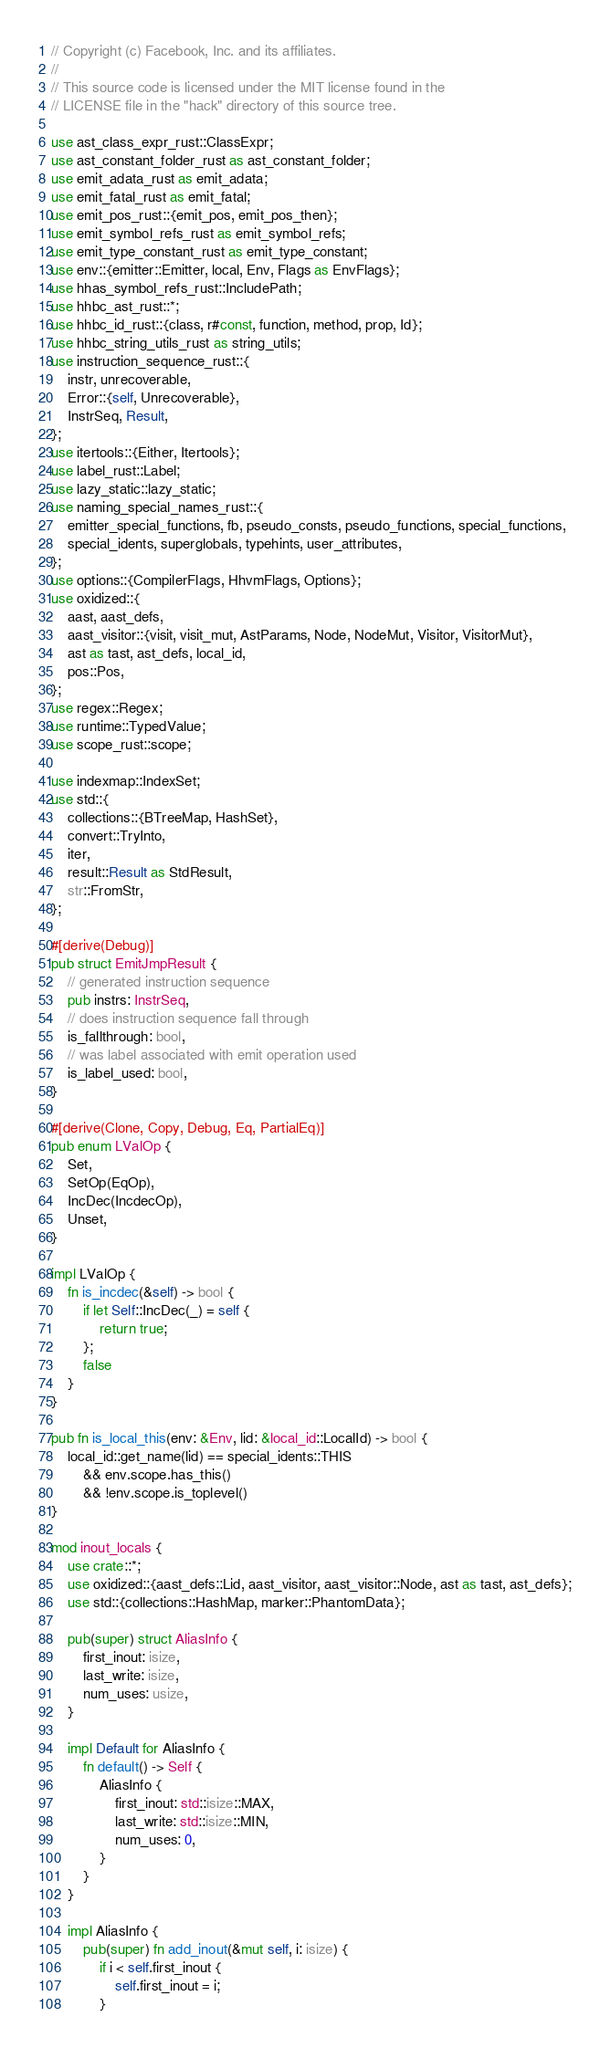Convert code to text. <code><loc_0><loc_0><loc_500><loc_500><_Rust_>// Copyright (c) Facebook, Inc. and its affiliates.
//
// This source code is licensed under the MIT license found in the
// LICENSE file in the "hack" directory of this source tree.

use ast_class_expr_rust::ClassExpr;
use ast_constant_folder_rust as ast_constant_folder;
use emit_adata_rust as emit_adata;
use emit_fatal_rust as emit_fatal;
use emit_pos_rust::{emit_pos, emit_pos_then};
use emit_symbol_refs_rust as emit_symbol_refs;
use emit_type_constant_rust as emit_type_constant;
use env::{emitter::Emitter, local, Env, Flags as EnvFlags};
use hhas_symbol_refs_rust::IncludePath;
use hhbc_ast_rust::*;
use hhbc_id_rust::{class, r#const, function, method, prop, Id};
use hhbc_string_utils_rust as string_utils;
use instruction_sequence_rust::{
    instr, unrecoverable,
    Error::{self, Unrecoverable},
    InstrSeq, Result,
};
use itertools::{Either, Itertools};
use label_rust::Label;
use lazy_static::lazy_static;
use naming_special_names_rust::{
    emitter_special_functions, fb, pseudo_consts, pseudo_functions, special_functions,
    special_idents, superglobals, typehints, user_attributes,
};
use options::{CompilerFlags, HhvmFlags, Options};
use oxidized::{
    aast, aast_defs,
    aast_visitor::{visit, visit_mut, AstParams, Node, NodeMut, Visitor, VisitorMut},
    ast as tast, ast_defs, local_id,
    pos::Pos,
};
use regex::Regex;
use runtime::TypedValue;
use scope_rust::scope;

use indexmap::IndexSet;
use std::{
    collections::{BTreeMap, HashSet},
    convert::TryInto,
    iter,
    result::Result as StdResult,
    str::FromStr,
};

#[derive(Debug)]
pub struct EmitJmpResult {
    // generated instruction sequence
    pub instrs: InstrSeq,
    // does instruction sequence fall through
    is_fallthrough: bool,
    // was label associated with emit operation used
    is_label_used: bool,
}

#[derive(Clone, Copy, Debug, Eq, PartialEq)]
pub enum LValOp {
    Set,
    SetOp(EqOp),
    IncDec(IncdecOp),
    Unset,
}

impl LValOp {
    fn is_incdec(&self) -> bool {
        if let Self::IncDec(_) = self {
            return true;
        };
        false
    }
}

pub fn is_local_this(env: &Env, lid: &local_id::LocalId) -> bool {
    local_id::get_name(lid) == special_idents::THIS
        && env.scope.has_this()
        && !env.scope.is_toplevel()
}

mod inout_locals {
    use crate::*;
    use oxidized::{aast_defs::Lid, aast_visitor, aast_visitor::Node, ast as tast, ast_defs};
    use std::{collections::HashMap, marker::PhantomData};

    pub(super) struct AliasInfo {
        first_inout: isize,
        last_write: isize,
        num_uses: usize,
    }

    impl Default for AliasInfo {
        fn default() -> Self {
            AliasInfo {
                first_inout: std::isize::MAX,
                last_write: std::isize::MIN,
                num_uses: 0,
            }
        }
    }

    impl AliasInfo {
        pub(super) fn add_inout(&mut self, i: isize) {
            if i < self.first_inout {
                self.first_inout = i;
            }</code> 